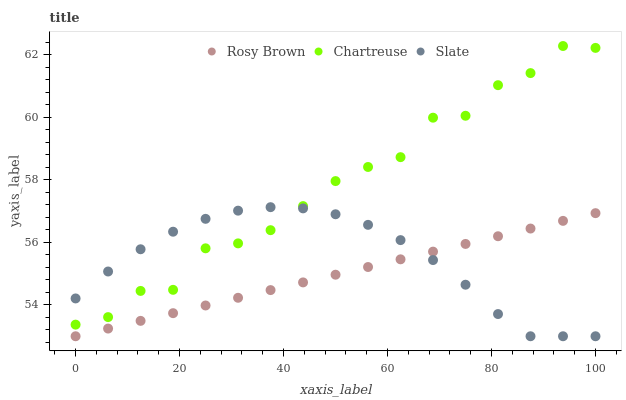Does Rosy Brown have the minimum area under the curve?
Answer yes or no. Yes. Does Chartreuse have the maximum area under the curve?
Answer yes or no. Yes. Does Slate have the minimum area under the curve?
Answer yes or no. No. Does Slate have the maximum area under the curve?
Answer yes or no. No. Is Rosy Brown the smoothest?
Answer yes or no. Yes. Is Chartreuse the roughest?
Answer yes or no. Yes. Is Slate the smoothest?
Answer yes or no. No. Is Slate the roughest?
Answer yes or no. No. Does Rosy Brown have the lowest value?
Answer yes or no. Yes. Does Chartreuse have the highest value?
Answer yes or no. Yes. Does Slate have the highest value?
Answer yes or no. No. Is Rosy Brown less than Chartreuse?
Answer yes or no. Yes. Is Chartreuse greater than Rosy Brown?
Answer yes or no. Yes. Does Rosy Brown intersect Slate?
Answer yes or no. Yes. Is Rosy Brown less than Slate?
Answer yes or no. No. Is Rosy Brown greater than Slate?
Answer yes or no. No. Does Rosy Brown intersect Chartreuse?
Answer yes or no. No. 